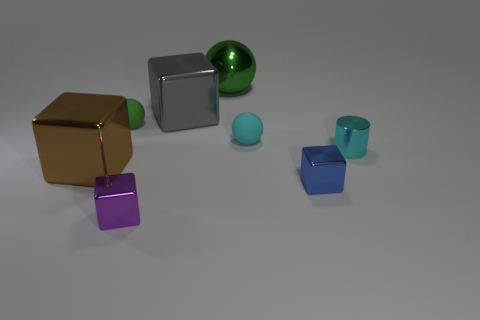Add 1 big yellow cylinders. How many objects exist? 9 Subtract all balls. How many objects are left? 5 Add 1 green metal things. How many green metal things are left? 2 Add 1 green balls. How many green balls exist? 3 Subtract 0 yellow cylinders. How many objects are left? 8 Subtract all cyan metal cylinders. Subtract all cyan rubber objects. How many objects are left? 6 